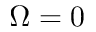<formula> <loc_0><loc_0><loc_500><loc_500>{ \Omega = 0 }</formula> 